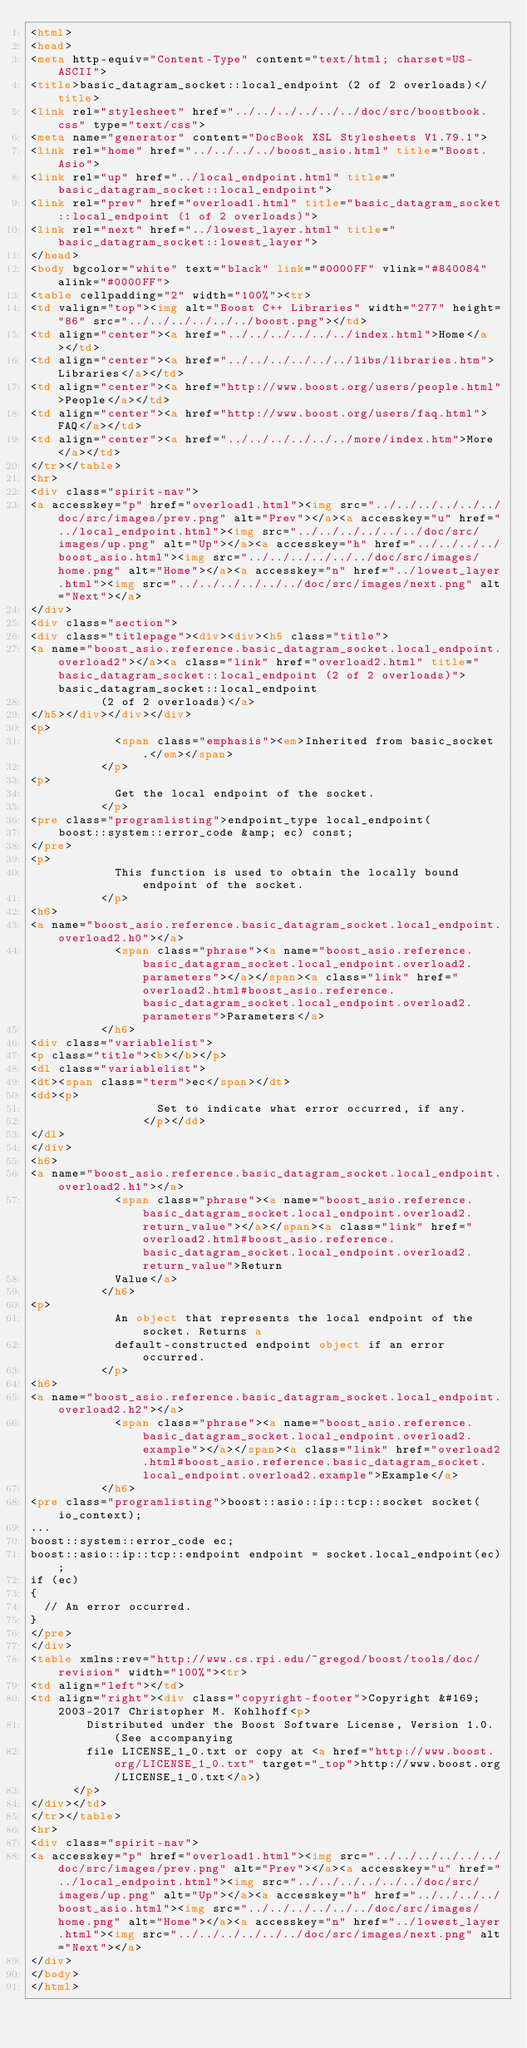Convert code to text. <code><loc_0><loc_0><loc_500><loc_500><_HTML_><html>
<head>
<meta http-equiv="Content-Type" content="text/html; charset=US-ASCII">
<title>basic_datagram_socket::local_endpoint (2 of 2 overloads)</title>
<link rel="stylesheet" href="../../../../../../doc/src/boostbook.css" type="text/css">
<meta name="generator" content="DocBook XSL Stylesheets V1.79.1">
<link rel="home" href="../../../../boost_asio.html" title="Boost.Asio">
<link rel="up" href="../local_endpoint.html" title="basic_datagram_socket::local_endpoint">
<link rel="prev" href="overload1.html" title="basic_datagram_socket::local_endpoint (1 of 2 overloads)">
<link rel="next" href="../lowest_layer.html" title="basic_datagram_socket::lowest_layer">
</head>
<body bgcolor="white" text="black" link="#0000FF" vlink="#840084" alink="#0000FF">
<table cellpadding="2" width="100%"><tr>
<td valign="top"><img alt="Boost C++ Libraries" width="277" height="86" src="../../../../../../boost.png"></td>
<td align="center"><a href="../../../../../../index.html">Home</a></td>
<td align="center"><a href="../../../../../../libs/libraries.htm">Libraries</a></td>
<td align="center"><a href="http://www.boost.org/users/people.html">People</a></td>
<td align="center"><a href="http://www.boost.org/users/faq.html">FAQ</a></td>
<td align="center"><a href="../../../../../../more/index.htm">More</a></td>
</tr></table>
<hr>
<div class="spirit-nav">
<a accesskey="p" href="overload1.html"><img src="../../../../../../doc/src/images/prev.png" alt="Prev"></a><a accesskey="u" href="../local_endpoint.html"><img src="../../../../../../doc/src/images/up.png" alt="Up"></a><a accesskey="h" href="../../../../boost_asio.html"><img src="../../../../../../doc/src/images/home.png" alt="Home"></a><a accesskey="n" href="../lowest_layer.html"><img src="../../../../../../doc/src/images/next.png" alt="Next"></a>
</div>
<div class="section">
<div class="titlepage"><div><div><h5 class="title">
<a name="boost_asio.reference.basic_datagram_socket.local_endpoint.overload2"></a><a class="link" href="overload2.html" title="basic_datagram_socket::local_endpoint (2 of 2 overloads)">basic_datagram_socket::local_endpoint
          (2 of 2 overloads)</a>
</h5></div></div></div>
<p>
            <span class="emphasis"><em>Inherited from basic_socket.</em></span>
          </p>
<p>
            Get the local endpoint of the socket.
          </p>
<pre class="programlisting">endpoint_type local_endpoint(
    boost::system::error_code &amp; ec) const;
</pre>
<p>
            This function is used to obtain the locally bound endpoint of the socket.
          </p>
<h6>
<a name="boost_asio.reference.basic_datagram_socket.local_endpoint.overload2.h0"></a>
            <span class="phrase"><a name="boost_asio.reference.basic_datagram_socket.local_endpoint.overload2.parameters"></a></span><a class="link" href="overload2.html#boost_asio.reference.basic_datagram_socket.local_endpoint.overload2.parameters">Parameters</a>
          </h6>
<div class="variablelist">
<p class="title"><b></b></p>
<dl class="variablelist">
<dt><span class="term">ec</span></dt>
<dd><p>
                  Set to indicate what error occurred, if any.
                </p></dd>
</dl>
</div>
<h6>
<a name="boost_asio.reference.basic_datagram_socket.local_endpoint.overload2.h1"></a>
            <span class="phrase"><a name="boost_asio.reference.basic_datagram_socket.local_endpoint.overload2.return_value"></a></span><a class="link" href="overload2.html#boost_asio.reference.basic_datagram_socket.local_endpoint.overload2.return_value">Return
            Value</a>
          </h6>
<p>
            An object that represents the local endpoint of the socket. Returns a
            default-constructed endpoint object if an error occurred.
          </p>
<h6>
<a name="boost_asio.reference.basic_datagram_socket.local_endpoint.overload2.h2"></a>
            <span class="phrase"><a name="boost_asio.reference.basic_datagram_socket.local_endpoint.overload2.example"></a></span><a class="link" href="overload2.html#boost_asio.reference.basic_datagram_socket.local_endpoint.overload2.example">Example</a>
          </h6>
<pre class="programlisting">boost::asio::ip::tcp::socket socket(io_context);
...
boost::system::error_code ec;
boost::asio::ip::tcp::endpoint endpoint = socket.local_endpoint(ec);
if (ec)
{
  // An error occurred.
}
</pre>
</div>
<table xmlns:rev="http://www.cs.rpi.edu/~gregod/boost/tools/doc/revision" width="100%"><tr>
<td align="left"></td>
<td align="right"><div class="copyright-footer">Copyright &#169; 2003-2017 Christopher M. Kohlhoff<p>
        Distributed under the Boost Software License, Version 1.0. (See accompanying
        file LICENSE_1_0.txt or copy at <a href="http://www.boost.org/LICENSE_1_0.txt" target="_top">http://www.boost.org/LICENSE_1_0.txt</a>)
      </p>
</div></td>
</tr></table>
<hr>
<div class="spirit-nav">
<a accesskey="p" href="overload1.html"><img src="../../../../../../doc/src/images/prev.png" alt="Prev"></a><a accesskey="u" href="../local_endpoint.html"><img src="../../../../../../doc/src/images/up.png" alt="Up"></a><a accesskey="h" href="../../../../boost_asio.html"><img src="../../../../../../doc/src/images/home.png" alt="Home"></a><a accesskey="n" href="../lowest_layer.html"><img src="../../../../../../doc/src/images/next.png" alt="Next"></a>
</div>
</body>
</html>
</code> 